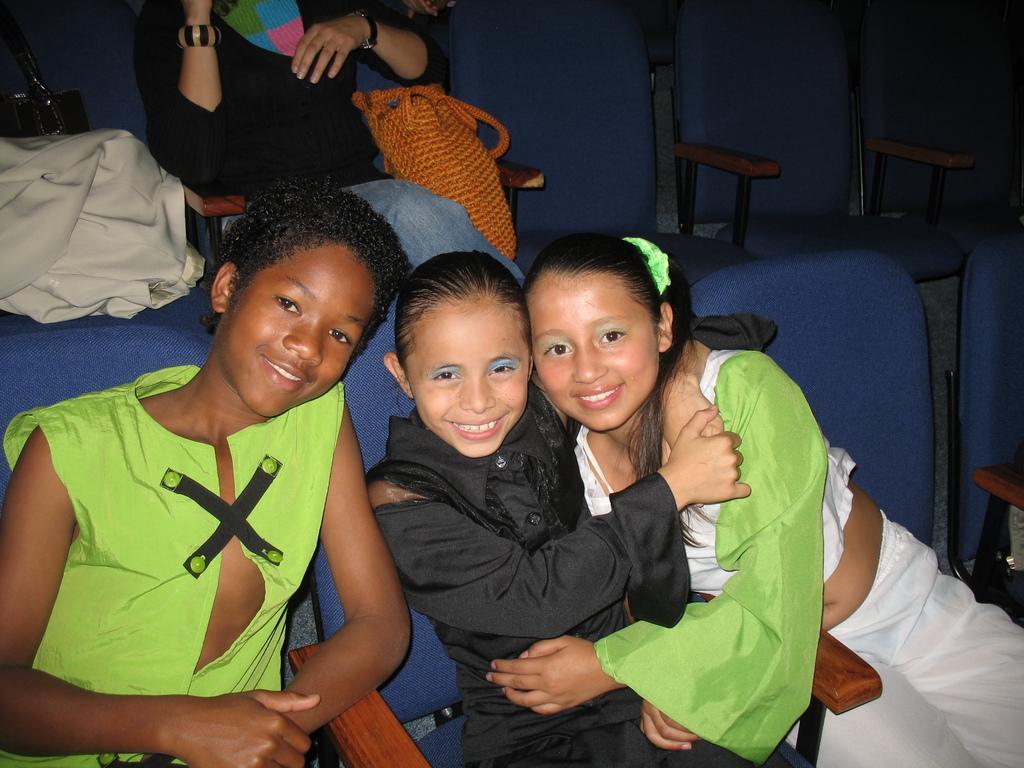Please provide a concise description of this image. In this image we can see two girls and one boy is sitting on the blue color chair. One girl is wearing green and white color top with white pant and the other girl is wearing black color dress. The boy is wearing green color jacket. We can see a woman is sitting on the chair at the top of the image. She is wearing black color top with jeans. Beside her, orange color bag is there and chairs are there. We can see cloth and black color bag on the chair which is in the left top of the image. 